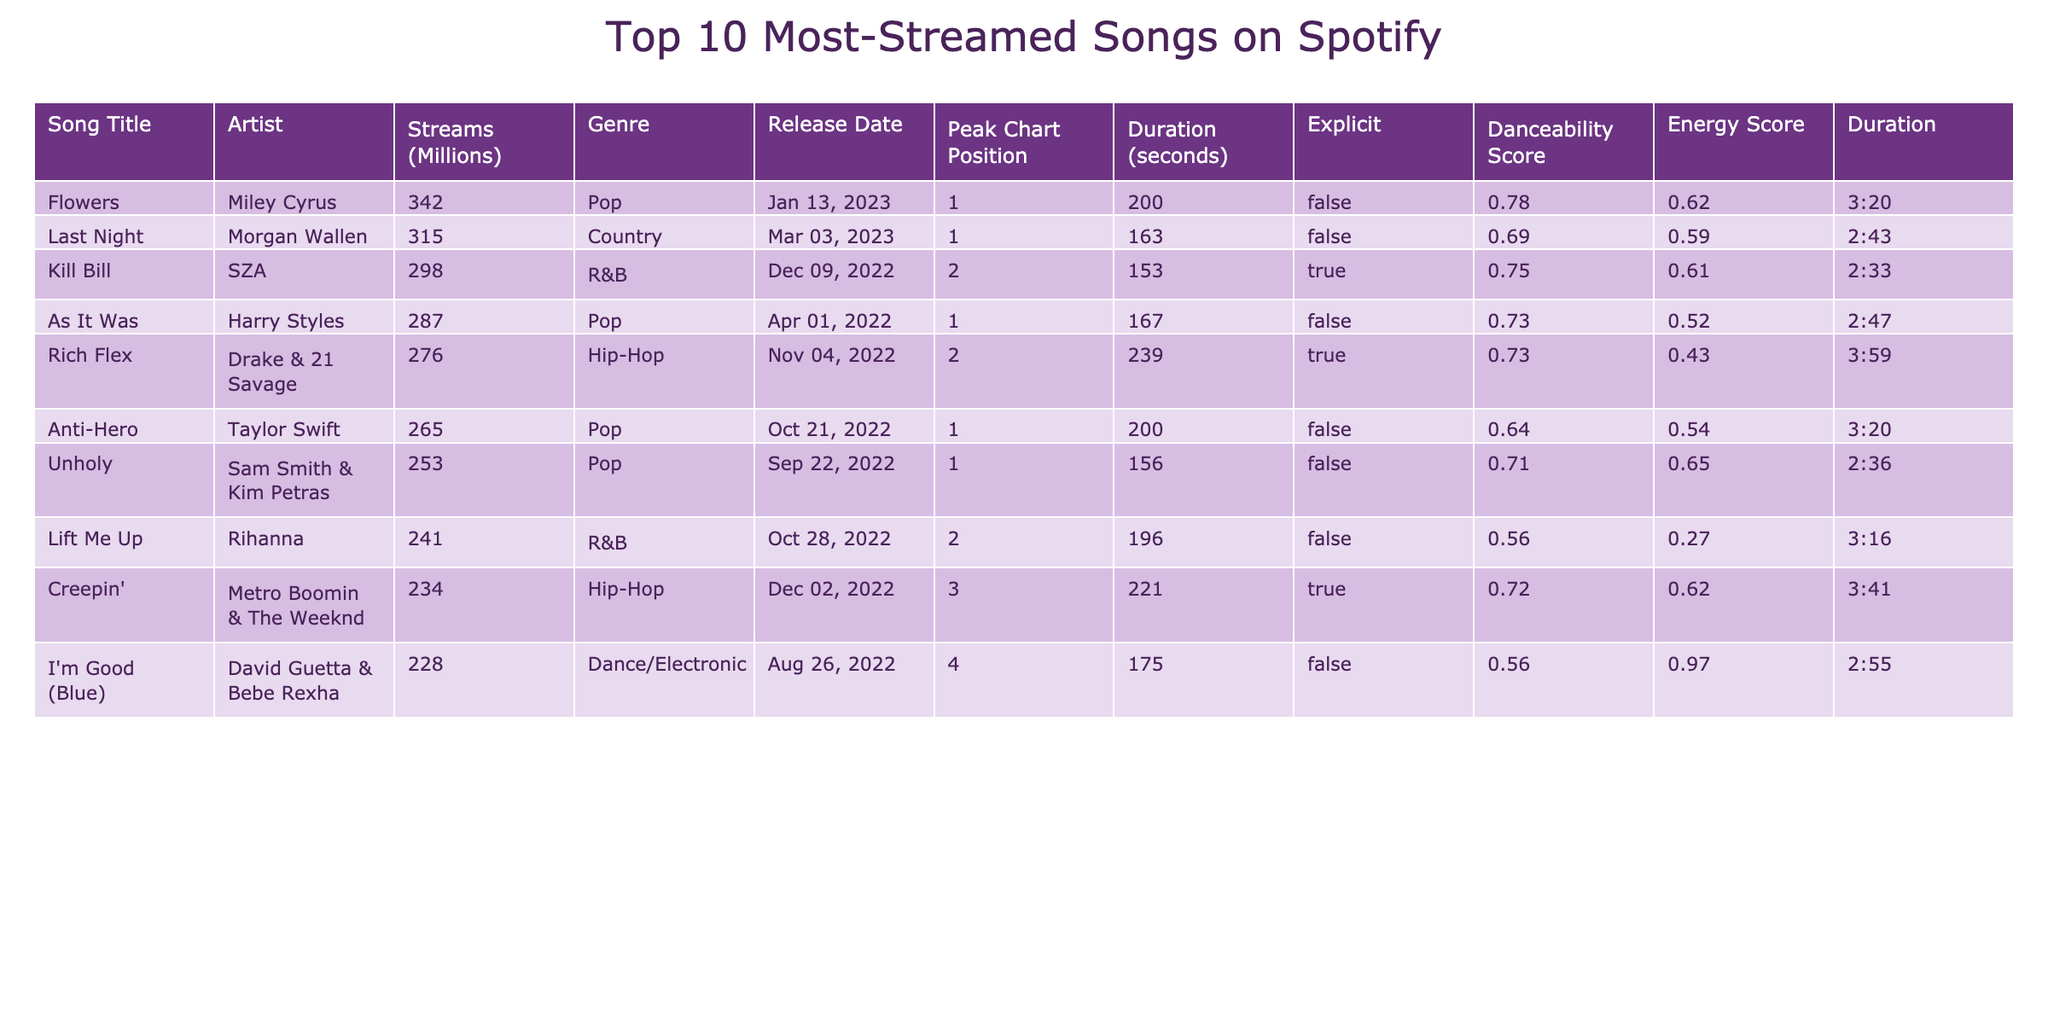What is the song with the highest number of streams? The "Streams (Millions)" column shows the highest value is 342 for "Flowers" by Miley Cyrus.
Answer: Flowers Which artist has the second most-streamed song? "Last Night" by Morgan Wallen has the second highest streams at 315 million.
Answer: Morgan Wallen Are there any songs with explicit content in the top 10? Looking at the "Explicit" column, "Kill Bill," "Rich Flex," and "Creepin'" are marked as explicit.
Answer: Yes What is the total number of streams for all songs in the table? Sum of all streams: 342 + 315 + 298 + 287 + 276 + 265 + 253 + 241 + 234 + 228 = 2,588 million streams total.
Answer: 2588 million What is the release date of the oldest song in the list? The release dates show "As It Was" by Harry Styles was released on April 1, 2022, making it the earliest song listed.
Answer: April 1, 2022 Which genre has the most songs in the top 10? "Pop" appears 5 times in the genre column compared to others.
Answer: Pop Calculate the average duration of the songs in seconds. Total duration: 200 + 163 + 153 + 167 + 239 + 200 + 156 + 196 + 221 + 175 = 1,877 seconds; Divide by 10 for average: 1,877/10 = 187.7 seconds.
Answer: 187.7 seconds What is the peak chart position of "Unholy"? The table indicates "Unholy" peaked at position 1.
Answer: 1 How many songs had a danceability score above 0.7? The danceability scores of the songs are 0.78, 0.69, 0.75, 0.73, 0.73, 0.64, 0.71, 0.56, 0.72, and 0.56. The scores above 0.7 are the first, third, fourth, fifth, and sixth songs, totaling 5.
Answer: 5 Which song has the longest duration? By comparing the duration in seconds, "Rich Flex" has the longest duration at 239 seconds.
Answer: Rich Flex 